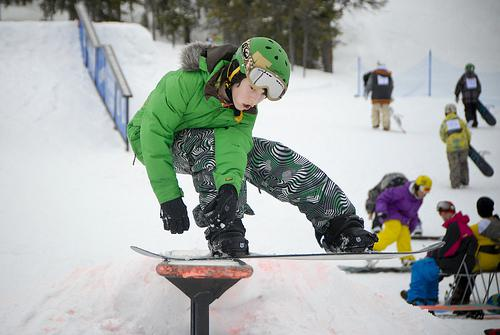Question: what is in the background?
Choices:
A. Trees.
B. Buildings.
C. Mountains.
D. Fence.
Answer with the letter. Answer: A Question: where is a green helmet?
Choices:
A. In his hand.
B. On a person's head.
C. On the ground.
D. Hanging on the pole.
Answer with the letter. Answer: B Question: what is green?
Choices:
A. A ski jacket.
B. The gloves.
C. The hat.
D. The poles.
Answer with the letter. Answer: A Question: where are goggles?
Choices:
A. On a kid's head.
B. On the ground.
C. In his hand.
D. In his pocket.
Answer with the letter. Answer: A Question: who is wearing green?
Choices:
A. A skier.
B. An attendant.
C. The baby.
D. A snowboarder.
Answer with the letter. Answer: D Question: what is yellow?
Choices:
A. Snow pants.
B. Gloves.
C. Hat.
D. Helmet.
Answer with the letter. Answer: A 